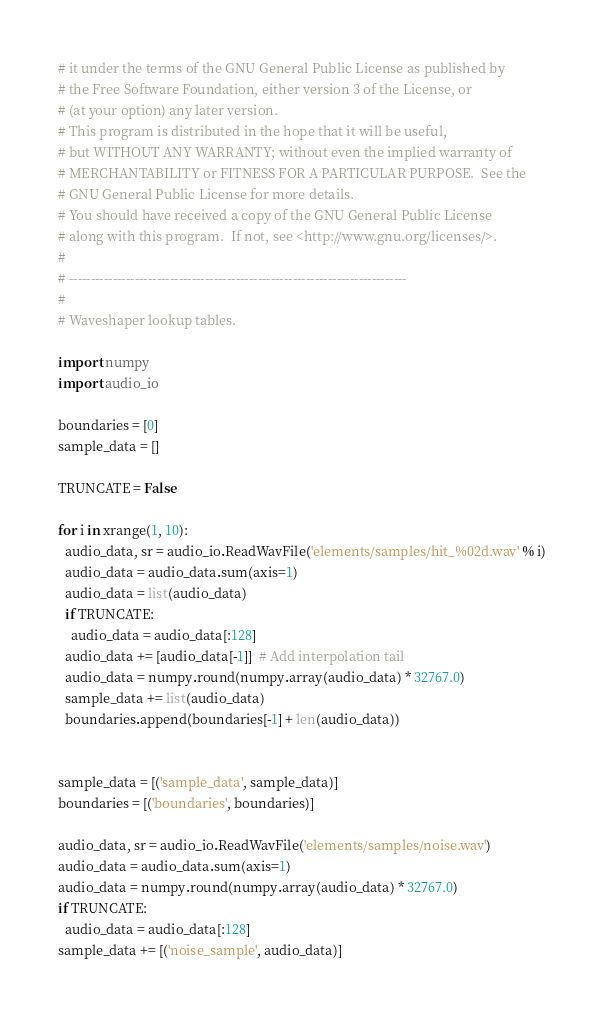Convert code to text. <code><loc_0><loc_0><loc_500><loc_500><_Python_># it under the terms of the GNU General Public License as published by
# the Free Software Foundation, either version 3 of the License, or
# (at your option) any later version.
# This program is distributed in the hope that it will be useful,
# but WITHOUT ANY WARRANTY; without even the implied warranty of
# MERCHANTABILITY or FITNESS FOR A PARTICULAR PURPOSE.  See the
# GNU General Public License for more details.
# You should have received a copy of the GNU General Public License
# along with this program.  If not, see <http://www.gnu.org/licenses/>.
#
# -----------------------------------------------------------------------------
#
# Waveshaper lookup tables.

import numpy
import audio_io

boundaries = [0]
sample_data = []

TRUNCATE = False

for i in xrange(1, 10):
  audio_data, sr = audio_io.ReadWavFile('elements/samples/hit_%02d.wav' % i)
  audio_data = audio_data.sum(axis=1)
  audio_data = list(audio_data)
  if TRUNCATE:
    audio_data = audio_data[:128]
  audio_data += [audio_data[-1]]  # Add interpolation tail
  audio_data = numpy.round(numpy.array(audio_data) * 32767.0)
  sample_data += list(audio_data)
  boundaries.append(boundaries[-1] + len(audio_data))


sample_data = [('sample_data', sample_data)]
boundaries = [('boundaries', boundaries)]

audio_data, sr = audio_io.ReadWavFile('elements/samples/noise.wav')
audio_data = audio_data.sum(axis=1)
audio_data = numpy.round(numpy.array(audio_data) * 32767.0)
if TRUNCATE:
  audio_data = audio_data[:128]
sample_data += [('noise_sample', audio_data)]

</code> 